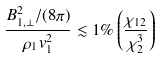Convert formula to latex. <formula><loc_0><loc_0><loc_500><loc_500>\frac { B _ { 1 , \perp } ^ { 2 } / ( 8 \pi ) } { \rho _ { 1 } v _ { 1 } ^ { 2 } } \lesssim 1 \% \left ( \frac { \chi _ { 1 2 } } { \chi _ { 2 } ^ { 3 } } \right )</formula> 